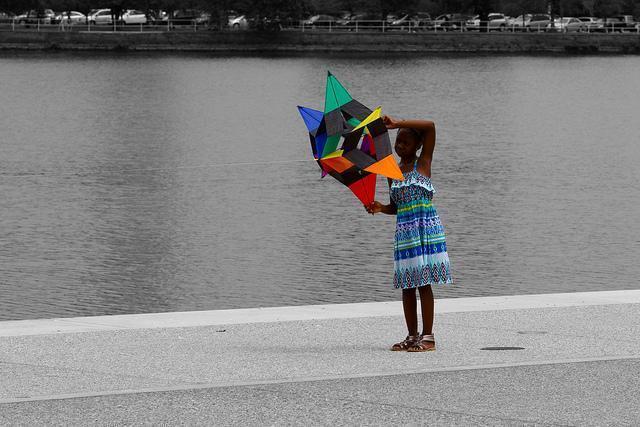Where does the girl want the toy she holds to go?
Select the accurate response from the four choices given to answer the question.
Options: Skyward, nowhere, down, sideways. Skyward. 